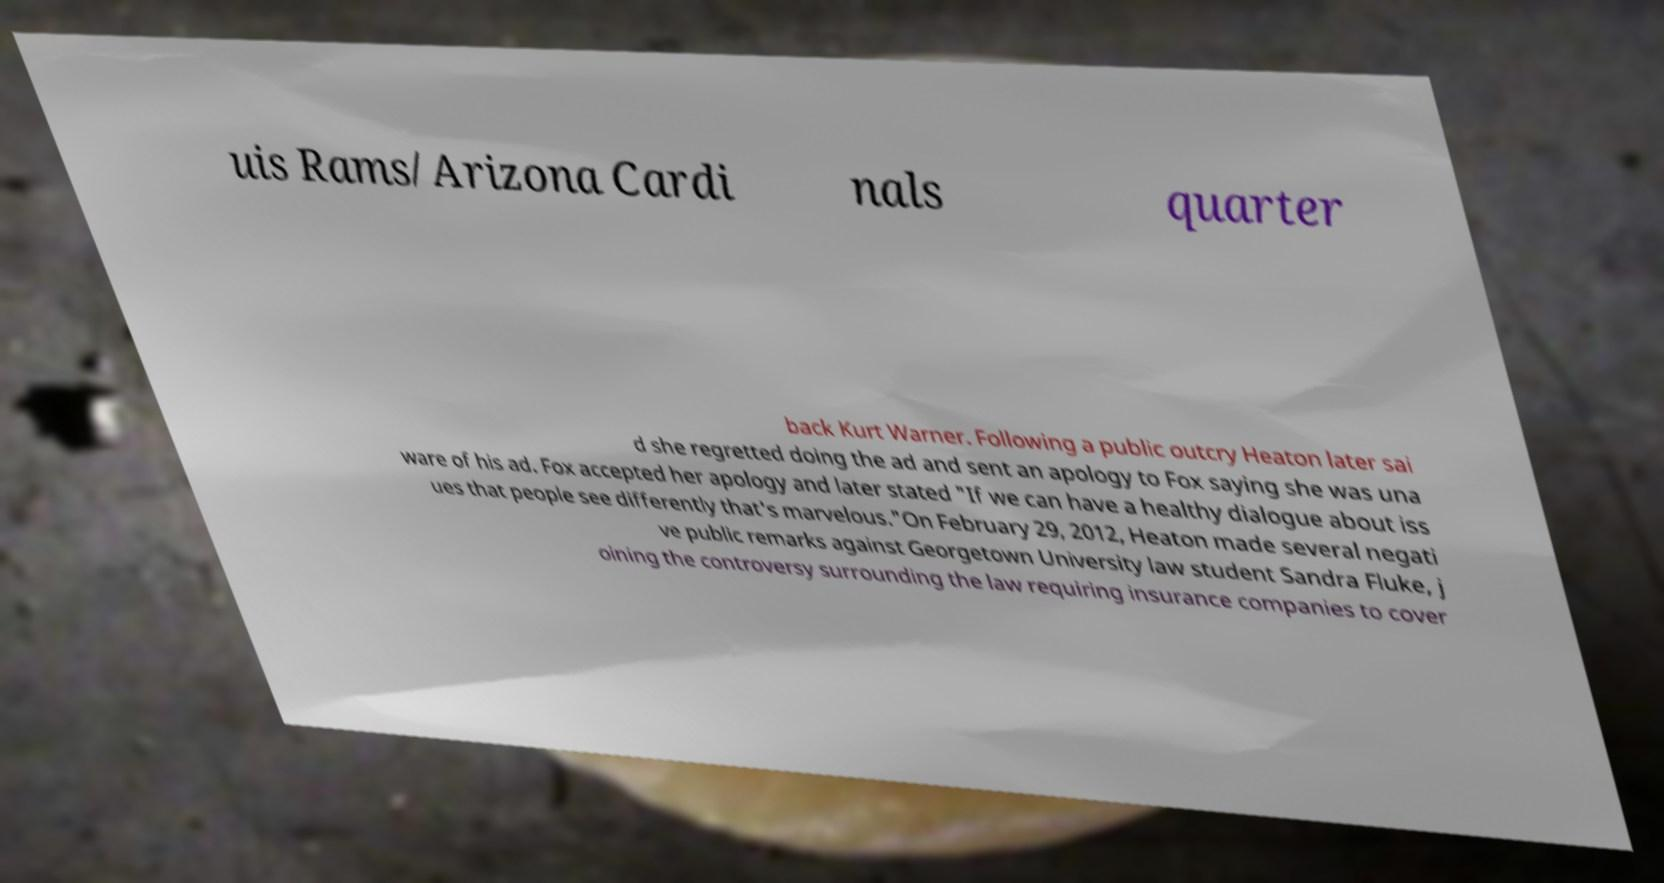Can you accurately transcribe the text from the provided image for me? uis Rams/Arizona Cardi nals quarter back Kurt Warner. Following a public outcry Heaton later sai d she regretted doing the ad and sent an apology to Fox saying she was una ware of his ad. Fox accepted her apology and later stated "If we can have a healthy dialogue about iss ues that people see differently that's marvelous."On February 29, 2012, Heaton made several negati ve public remarks against Georgetown University law student Sandra Fluke, j oining the controversy surrounding the law requiring insurance companies to cover 